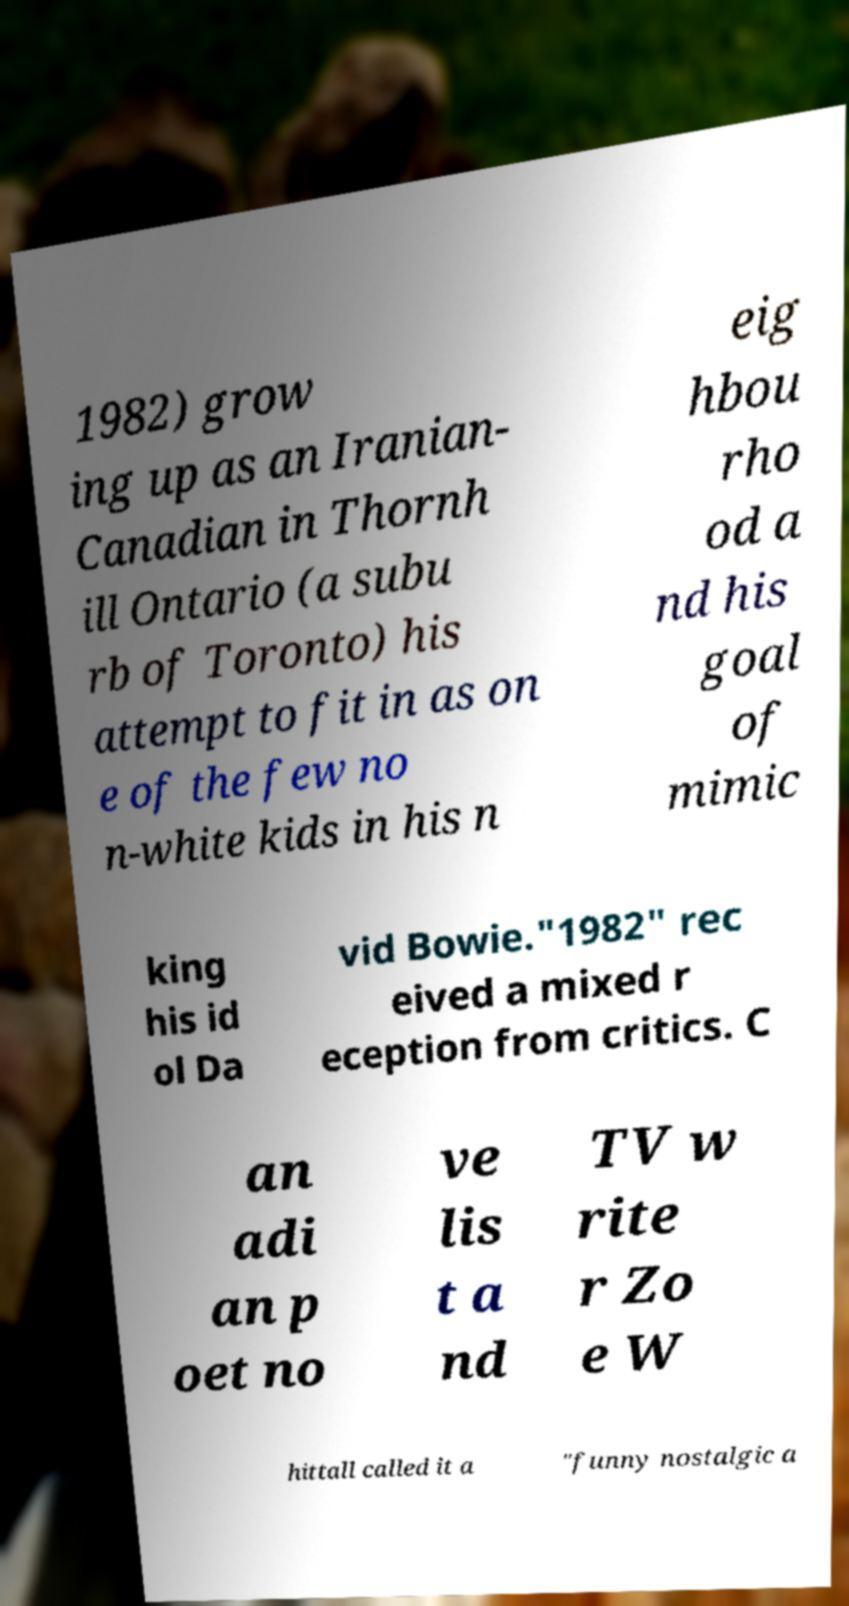Could you assist in decoding the text presented in this image and type it out clearly? 1982) grow ing up as an Iranian- Canadian in Thornh ill Ontario (a subu rb of Toronto) his attempt to fit in as on e of the few no n-white kids in his n eig hbou rho od a nd his goal of mimic king his id ol Da vid Bowie."1982" rec eived a mixed r eception from critics. C an adi an p oet no ve lis t a nd TV w rite r Zo e W hittall called it a "funny nostalgic a 